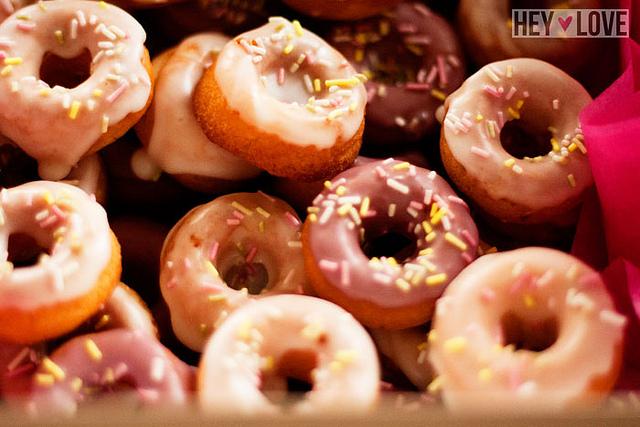How many different type of donuts are there?
Write a very short answer. 3. What is on top of the donuts?
Be succinct. Sprinkles. How much sugar do you guess was used to make these donuts?
Keep it brief. Lot. 